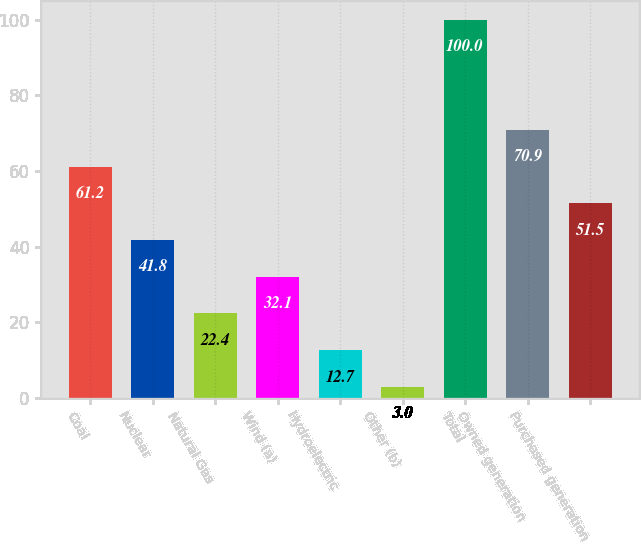<chart> <loc_0><loc_0><loc_500><loc_500><bar_chart><fcel>Coal<fcel>Nuclear<fcel>Natural Gas<fcel>Wind (a)<fcel>Hydroelectric<fcel>Other (b)<fcel>Total<fcel>Owned generation<fcel>Purchased generation<nl><fcel>61.2<fcel>41.8<fcel>22.4<fcel>32.1<fcel>12.7<fcel>3<fcel>100<fcel>70.9<fcel>51.5<nl></chart> 